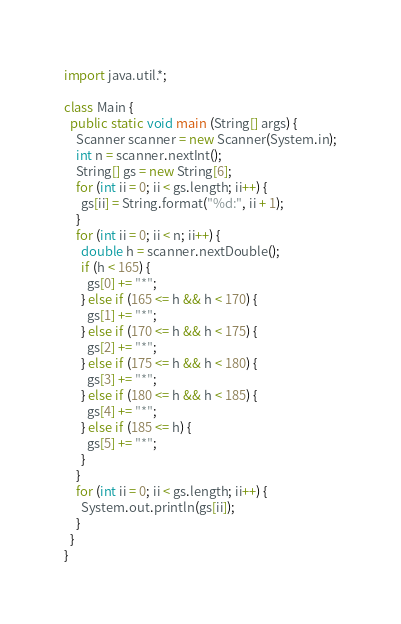Convert code to text. <code><loc_0><loc_0><loc_500><loc_500><_Java_>import java.util.*;

class Main {
  public static void main (String[] args) {
    Scanner scanner = new Scanner(System.in);
    int n = scanner.nextInt();
    String[] gs = new String[6];
    for (int ii = 0; ii < gs.length; ii++) {
      gs[ii] = String.format("%d:", ii + 1);
    }
    for (int ii = 0; ii < n; ii++) {
      double h = scanner.nextDouble();
      if (h < 165) {
        gs[0] += "*";
      } else if (165 <= h && h < 170) {
        gs[1] += "*";
      } else if (170 <= h && h < 175) {
        gs[2] += "*";
      } else if (175 <= h && h < 180) {
        gs[3] += "*";
      } else if (180 <= h && h < 185) {
        gs[4] += "*";
      } else if (185 <= h) {
        gs[5] += "*";
      }
    }
    for (int ii = 0; ii < gs.length; ii++) {
      System.out.println(gs[ii]);
    }
  }
}</code> 